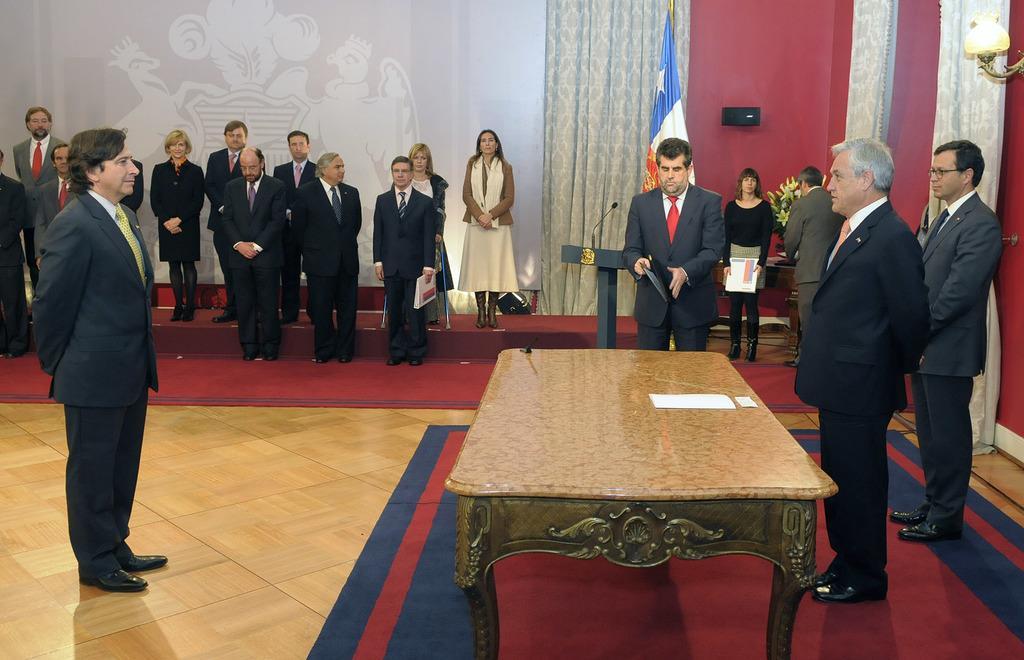Please provide a concise description of this image. This is an inside view. Here I can see many people standing on the floor. On the right side there is a table and a podium. On the table, I can see a paper. In the background there is a flag and also I can see few curtains on the wall. 